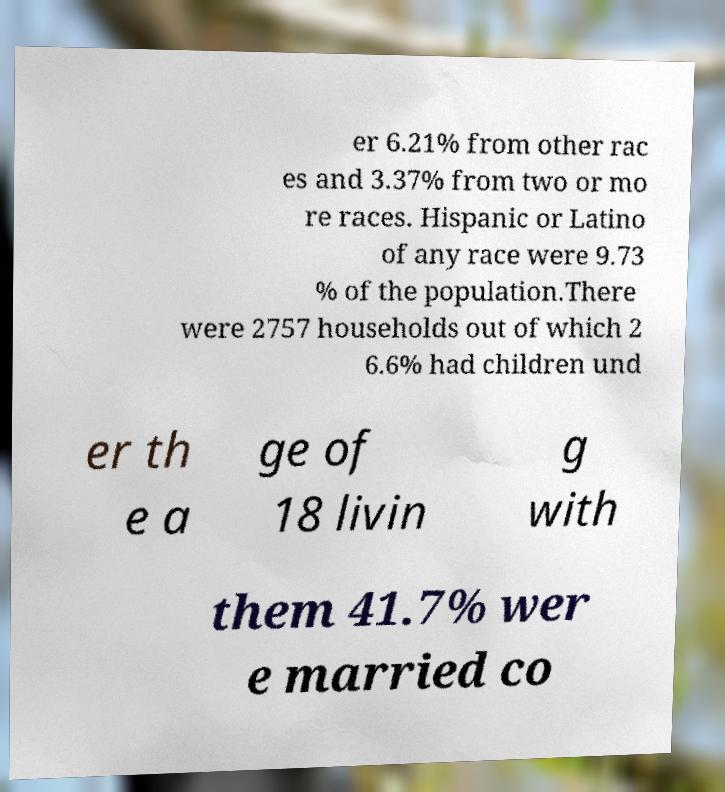Can you read and provide the text displayed in the image?This photo seems to have some interesting text. Can you extract and type it out for me? er 6.21% from other rac es and 3.37% from two or mo re races. Hispanic or Latino of any race were 9.73 % of the population.There were 2757 households out of which 2 6.6% had children und er th e a ge of 18 livin g with them 41.7% wer e married co 